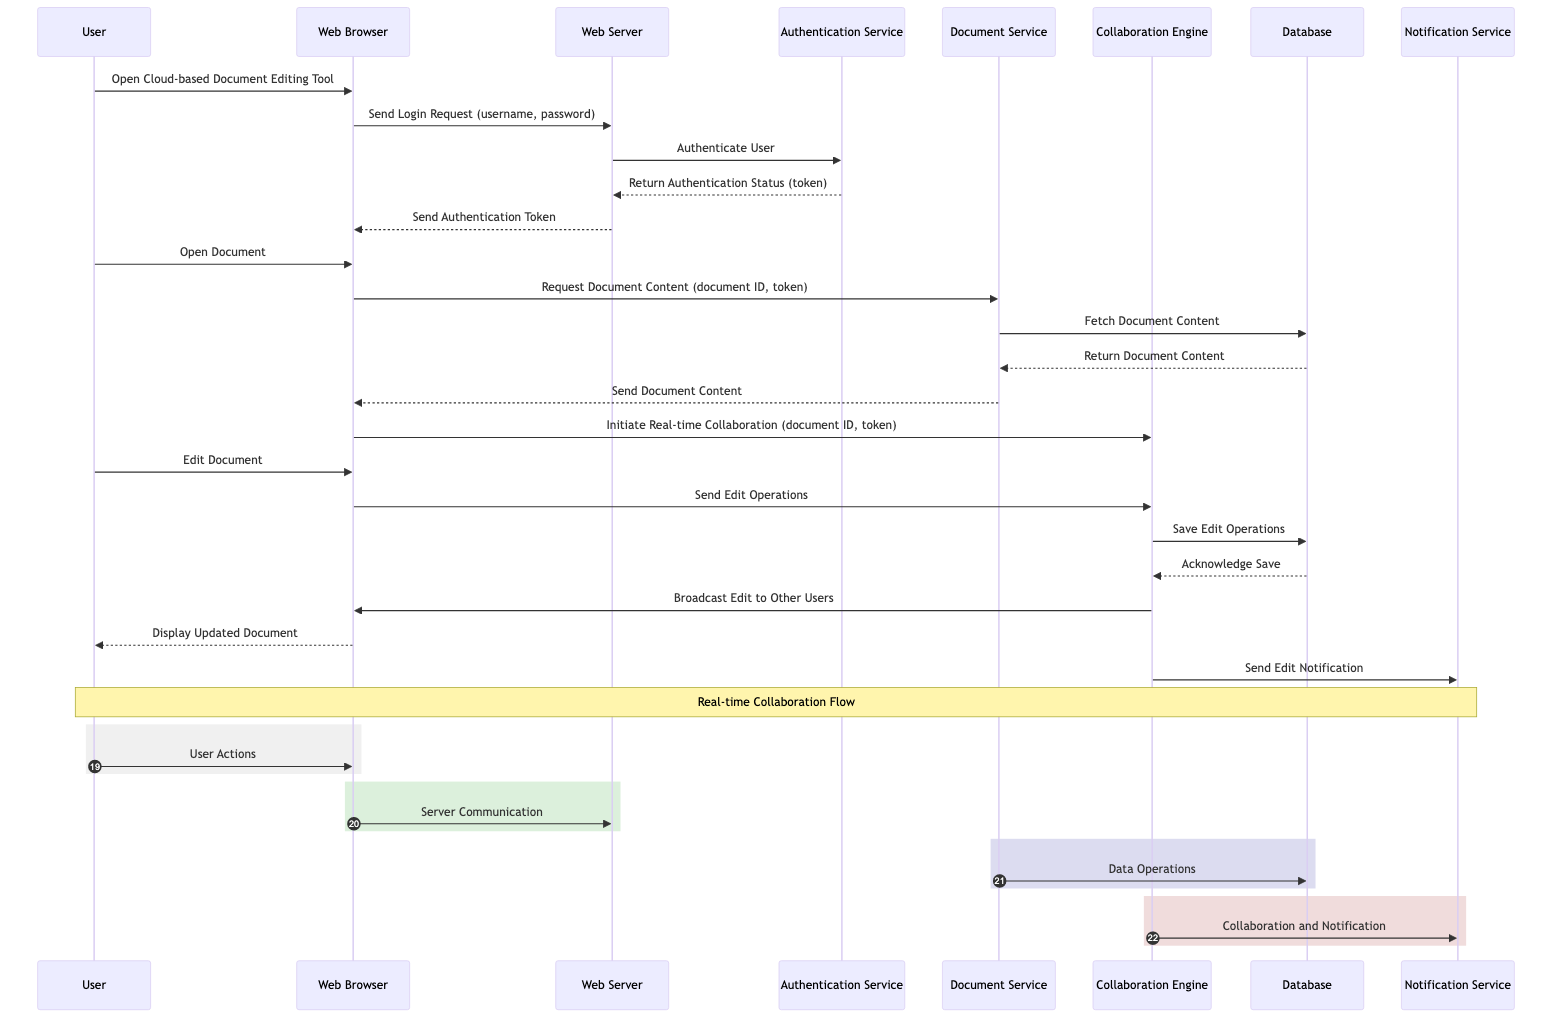What is the first action taken by the User? The diagram starts with the User opening the Cloud-based Document Editing Tool. This is specified as the first interaction in the sequence.
Answer: Open Cloud-based Document Editing Tool Who authenticates the User? The interaction specifies that the Web Server sends the authentication request to the Authentication Service, making it responsible for authenticating the User.
Answer: Authentication Service How many entities are involved in the diagram? A count of the entities listed shows there are eight entities involved in this sequence diagram.
Answer: Eight What does the Web Browser do after receiving the authentication token? The Web Browser, after getting the authentication token, allows the User to open a document. This follows the sequence where the User interacts with the Web Browser immediately after receiving the token.
Answer: Open Document What is the last action taken by the Notification Service? The final action noted in the sequence by the Notification Service is sending an edit notification, which indicates it conveys information about the edit operations completed.
Answer: Send Edit Notification What happens after the User edits the document? Once the User edits the document, the Web Browser sends those edit operations to the Collaboration Engine, indicating the flow of information for collaborative editing takes place.
Answer: Send Edit Operations Which component is responsible for saving edit operations? The Collaboration Engine is shown to save the edit operations into the Database, indicating its role in handling collaboration tasks including saving changes made by Users.
Answer: Collaboration Engine What type of notifications does the Collaboration Engine send? The Collaboration Engine sends edit notifications to inform other Users about the changes made during collaboration, which indicates it supports real-time updates within the tool.
Answer: Edit Notification How does the Collaboration Engine communicate updates to other Users? After saving the edit operations in the Database, the Collaboration Engine broadcasts these edits to other Users through the Web Browser, demonstrating its role in real-time collaboration.
Answer: Broadcast Edit to Other Users 